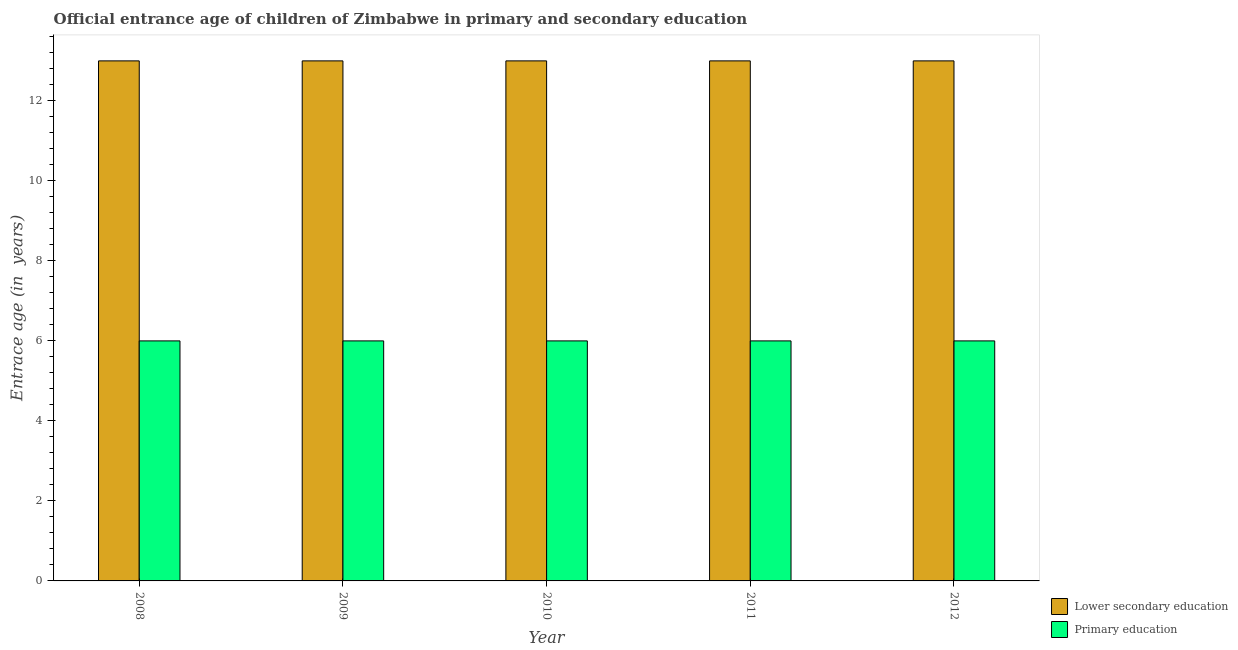How many groups of bars are there?
Provide a succinct answer. 5. Are the number of bars per tick equal to the number of legend labels?
Your response must be concise. Yes. How many bars are there on the 2nd tick from the left?
Your answer should be very brief. 2. How many bars are there on the 5th tick from the right?
Keep it short and to the point. 2. What is the label of the 3rd group of bars from the left?
Give a very brief answer. 2010. What is the entrance age of chiildren in primary education in 2010?
Ensure brevity in your answer.  6. Across all years, what is the minimum entrance age of children in lower secondary education?
Provide a succinct answer. 13. In which year was the entrance age of children in lower secondary education maximum?
Ensure brevity in your answer.  2008. In which year was the entrance age of chiildren in primary education minimum?
Your answer should be very brief. 2008. What is the total entrance age of children in lower secondary education in the graph?
Make the answer very short. 65. What is the difference between the entrance age of children in lower secondary education in 2009 and the entrance age of chiildren in primary education in 2008?
Offer a very short reply. 0. In the year 2012, what is the difference between the entrance age of chiildren in primary education and entrance age of children in lower secondary education?
Ensure brevity in your answer.  0. In how many years, is the entrance age of children in lower secondary education greater than 13.2 years?
Your answer should be compact. 0. What is the ratio of the entrance age of children in lower secondary education in 2008 to that in 2012?
Provide a succinct answer. 1. What is the difference between the highest and the second highest entrance age of chiildren in primary education?
Your answer should be very brief. 0. In how many years, is the entrance age of chiildren in primary education greater than the average entrance age of chiildren in primary education taken over all years?
Provide a succinct answer. 0. What does the 1st bar from the left in 2010 represents?
Provide a short and direct response. Lower secondary education. What does the 2nd bar from the right in 2011 represents?
Offer a very short reply. Lower secondary education. Where does the legend appear in the graph?
Provide a succinct answer. Bottom right. What is the title of the graph?
Your response must be concise. Official entrance age of children of Zimbabwe in primary and secondary education. Does "Urban agglomerations" appear as one of the legend labels in the graph?
Your answer should be compact. No. What is the label or title of the Y-axis?
Give a very brief answer. Entrace age (in  years). What is the Entrace age (in  years) in Primary education in 2009?
Provide a succinct answer. 6. What is the Entrace age (in  years) in Primary education in 2010?
Ensure brevity in your answer.  6. What is the Entrace age (in  years) in Lower secondary education in 2012?
Give a very brief answer. 13. Across all years, what is the maximum Entrace age (in  years) of Lower secondary education?
Provide a short and direct response. 13. Across all years, what is the maximum Entrace age (in  years) of Primary education?
Your response must be concise. 6. What is the total Entrace age (in  years) of Lower secondary education in the graph?
Make the answer very short. 65. What is the total Entrace age (in  years) of Primary education in the graph?
Offer a very short reply. 30. What is the difference between the Entrace age (in  years) in Lower secondary education in 2008 and that in 2009?
Keep it short and to the point. 0. What is the difference between the Entrace age (in  years) in Primary education in 2008 and that in 2009?
Your answer should be compact. 0. What is the difference between the Entrace age (in  years) in Lower secondary education in 2008 and that in 2010?
Offer a very short reply. 0. What is the difference between the Entrace age (in  years) of Lower secondary education in 2008 and that in 2011?
Your answer should be compact. 0. What is the difference between the Entrace age (in  years) of Lower secondary education in 2008 and that in 2012?
Your answer should be very brief. 0. What is the difference between the Entrace age (in  years) in Lower secondary education in 2009 and that in 2010?
Your answer should be very brief. 0. What is the difference between the Entrace age (in  years) in Lower secondary education in 2009 and that in 2012?
Your answer should be compact. 0. What is the difference between the Entrace age (in  years) in Primary education in 2010 and that in 2011?
Your answer should be compact. 0. What is the difference between the Entrace age (in  years) of Primary education in 2010 and that in 2012?
Offer a terse response. 0. What is the difference between the Entrace age (in  years) in Lower secondary education in 2011 and that in 2012?
Your answer should be very brief. 0. What is the difference between the Entrace age (in  years) in Primary education in 2011 and that in 2012?
Provide a succinct answer. 0. What is the difference between the Entrace age (in  years) of Lower secondary education in 2008 and the Entrace age (in  years) of Primary education in 2010?
Offer a very short reply. 7. What is the difference between the Entrace age (in  years) in Lower secondary education in 2009 and the Entrace age (in  years) in Primary education in 2011?
Provide a succinct answer. 7. In the year 2008, what is the difference between the Entrace age (in  years) in Lower secondary education and Entrace age (in  years) in Primary education?
Offer a terse response. 7. In the year 2010, what is the difference between the Entrace age (in  years) of Lower secondary education and Entrace age (in  years) of Primary education?
Offer a very short reply. 7. In the year 2011, what is the difference between the Entrace age (in  years) of Lower secondary education and Entrace age (in  years) of Primary education?
Ensure brevity in your answer.  7. In the year 2012, what is the difference between the Entrace age (in  years) in Lower secondary education and Entrace age (in  years) in Primary education?
Make the answer very short. 7. What is the ratio of the Entrace age (in  years) in Lower secondary education in 2008 to that in 2009?
Make the answer very short. 1. What is the ratio of the Entrace age (in  years) of Primary education in 2008 to that in 2009?
Offer a terse response. 1. What is the ratio of the Entrace age (in  years) of Lower secondary education in 2008 to that in 2010?
Offer a very short reply. 1. What is the ratio of the Entrace age (in  years) of Lower secondary education in 2009 to that in 2011?
Provide a short and direct response. 1. What is the ratio of the Entrace age (in  years) in Primary education in 2009 to that in 2011?
Offer a very short reply. 1. What is the ratio of the Entrace age (in  years) in Lower secondary education in 2009 to that in 2012?
Offer a terse response. 1. What is the ratio of the Entrace age (in  years) in Lower secondary education in 2010 to that in 2011?
Your answer should be compact. 1. What is the ratio of the Entrace age (in  years) in Primary education in 2010 to that in 2011?
Your response must be concise. 1. What is the ratio of the Entrace age (in  years) in Lower secondary education in 2010 to that in 2012?
Your answer should be very brief. 1. What is the ratio of the Entrace age (in  years) of Primary education in 2011 to that in 2012?
Ensure brevity in your answer.  1. What is the difference between the highest and the second highest Entrace age (in  years) of Primary education?
Your answer should be very brief. 0. 